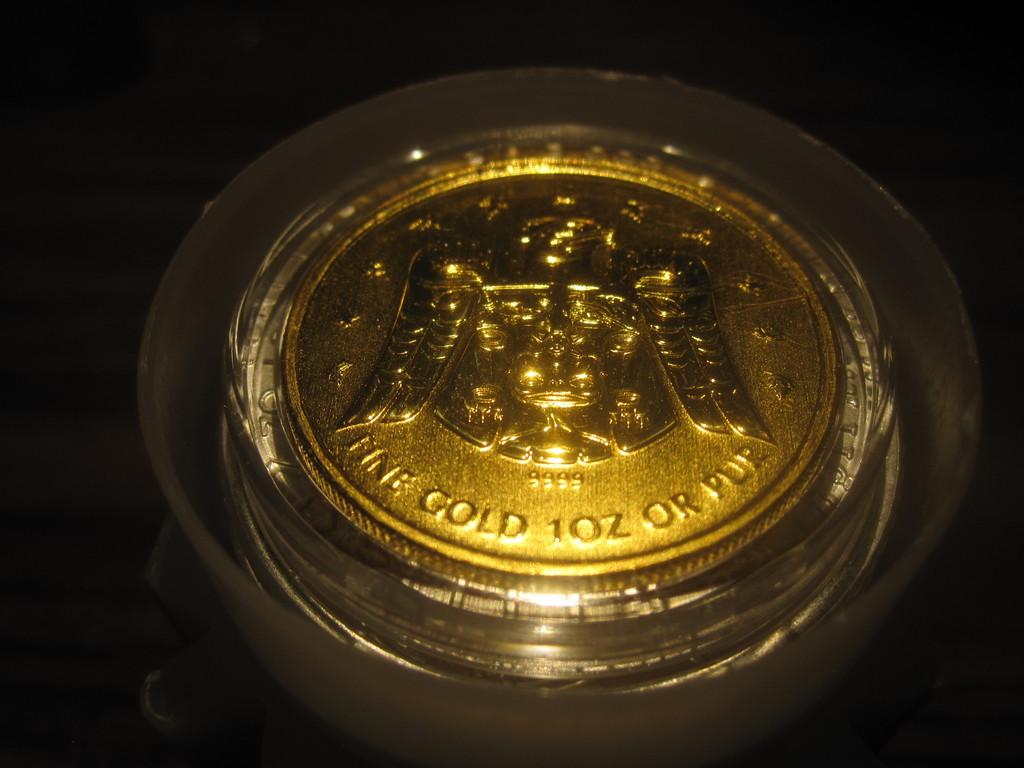<image>
Give a short and clear explanation of the subsequent image. A pure 10 ounce gold coin with an eagle in the center. 